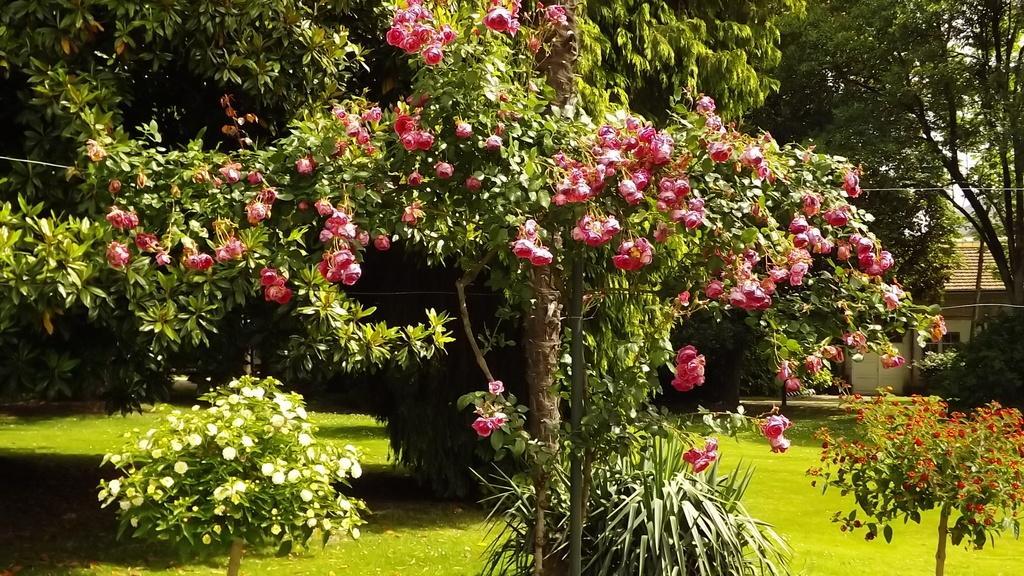In one or two sentences, can you explain what this image depicts? In the middle of this image, there is a tree having green color leaves and pink color flowers. On the left side, there is a plant having white color flowers. On the right side, there is another plant having flowers. In the background, there are trees, a building, sky and grass on the ground. 